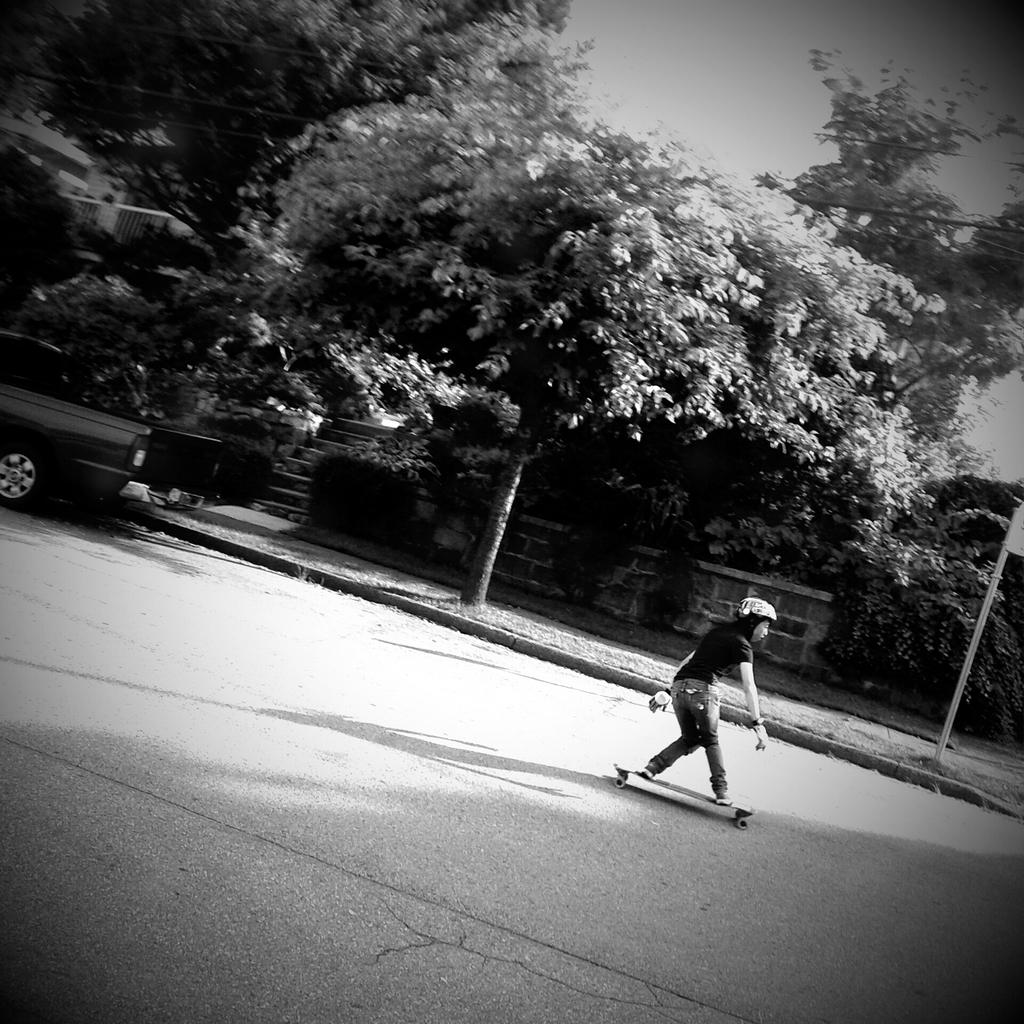Who is the main subject in the image? There is a woman in the image. What is the woman doing in the image? The woman is skating on the road. What can be seen in the background of the image? There are trees visible in the image. What else is present in the image besides the woman and trees? There is a vehicle and poles in the image. What is visible at the top of the image? The sky is visible at the top of the image. Are there any fairies flying around the woman in the image? No, there are no fairies present in the image. What type of zoo can be seen in the middle of the image? There is no zoo present in the image; it features a woman skating on the road with trees, a vehicle, and poles in the background. 